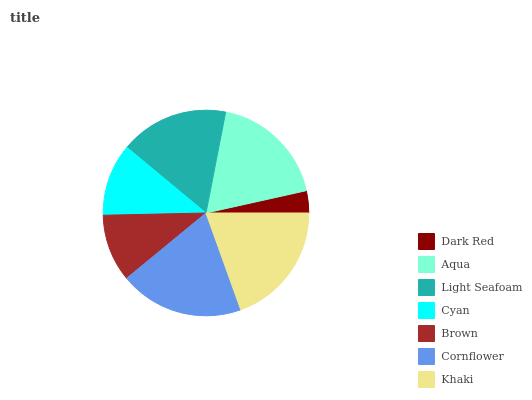Is Dark Red the minimum?
Answer yes or no. Yes. Is Cornflower the maximum?
Answer yes or no. Yes. Is Aqua the minimum?
Answer yes or no. No. Is Aqua the maximum?
Answer yes or no. No. Is Aqua greater than Dark Red?
Answer yes or no. Yes. Is Dark Red less than Aqua?
Answer yes or no. Yes. Is Dark Red greater than Aqua?
Answer yes or no. No. Is Aqua less than Dark Red?
Answer yes or no. No. Is Light Seafoam the high median?
Answer yes or no. Yes. Is Light Seafoam the low median?
Answer yes or no. Yes. Is Brown the high median?
Answer yes or no. No. Is Brown the low median?
Answer yes or no. No. 